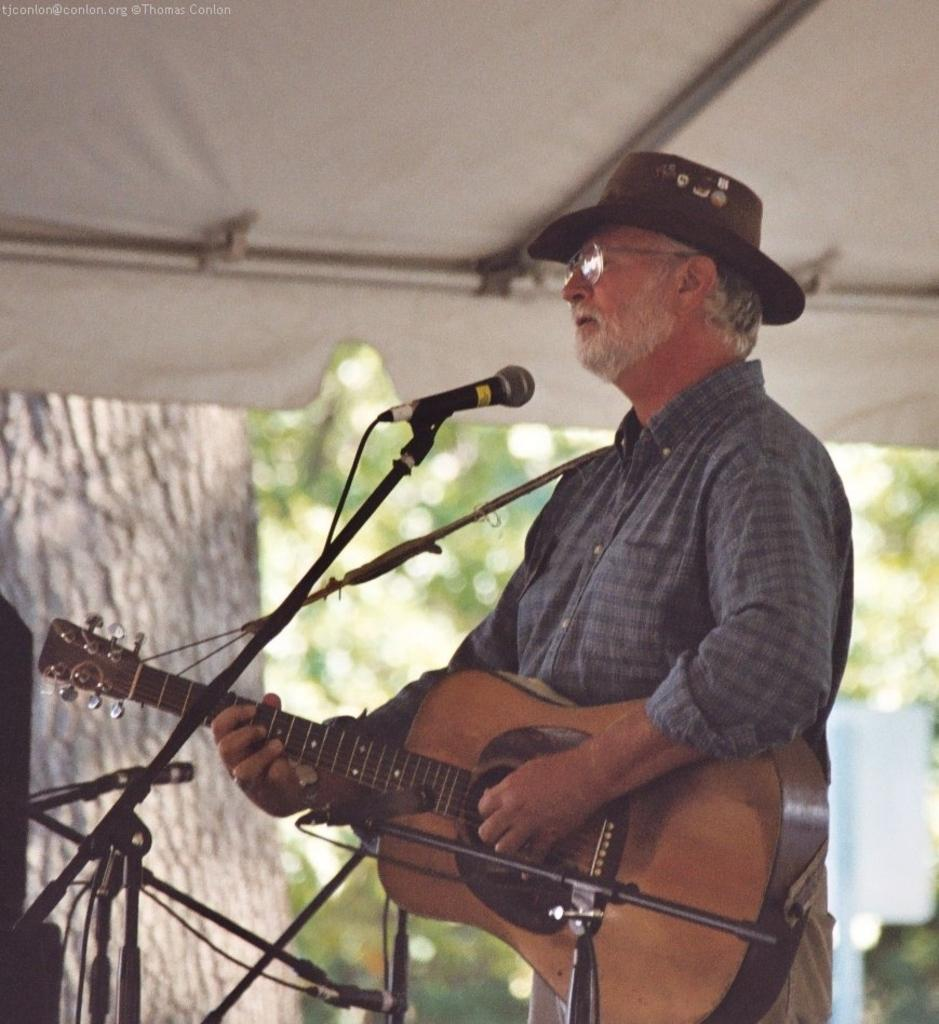What is the man in the image doing? The man is playing a guitar. How is the man positioned in the image? The man is standing. What is the man wearing on his head? The man is wearing a hat. What object is present for amplifying sound in the image? There is a microphone in the image. What is the man leaning on in the image? There is a stand in the image. What can be seen in the background of the image? There are trees in the background of the image. Is the girl in the image singing along with the man playing the guitar? There is no girl present in the image; it only features a man playing a guitar. 